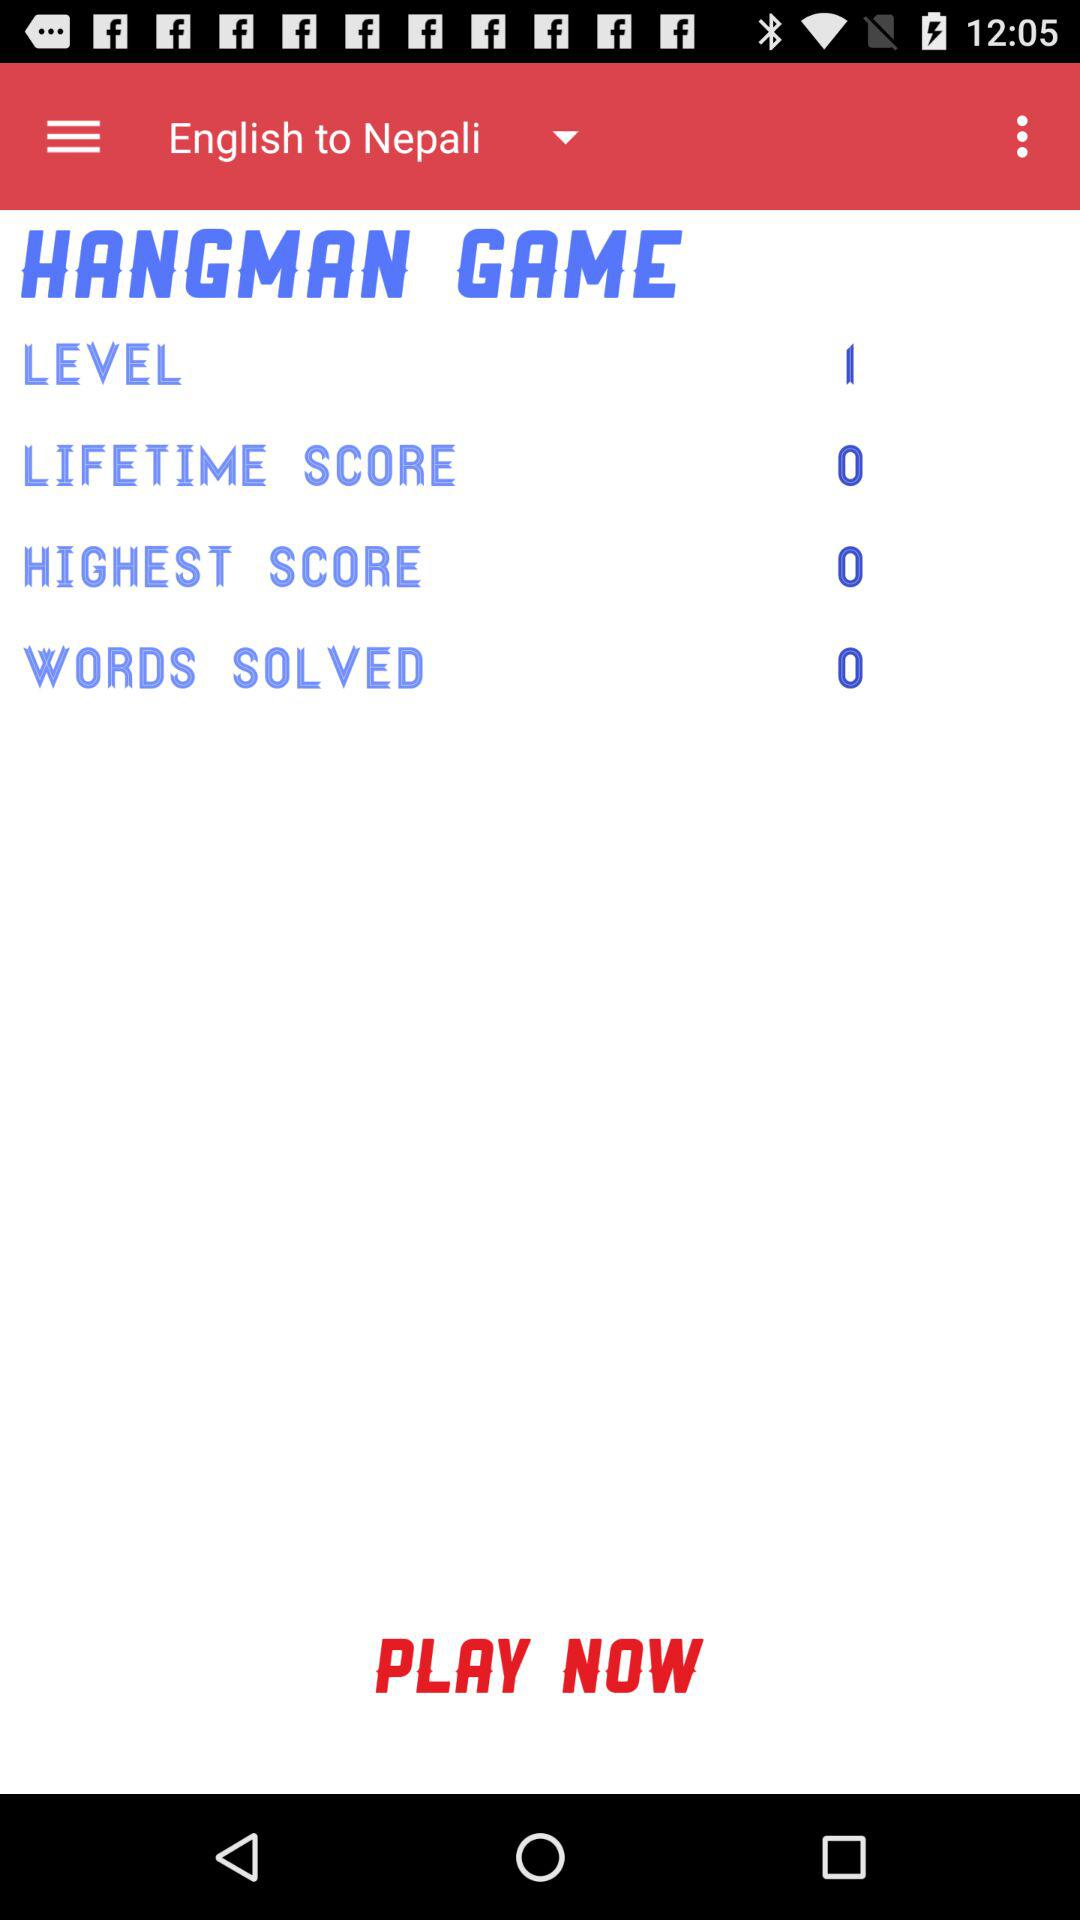What is the name of the game? The name of the game is "HANGMAN GAME". 